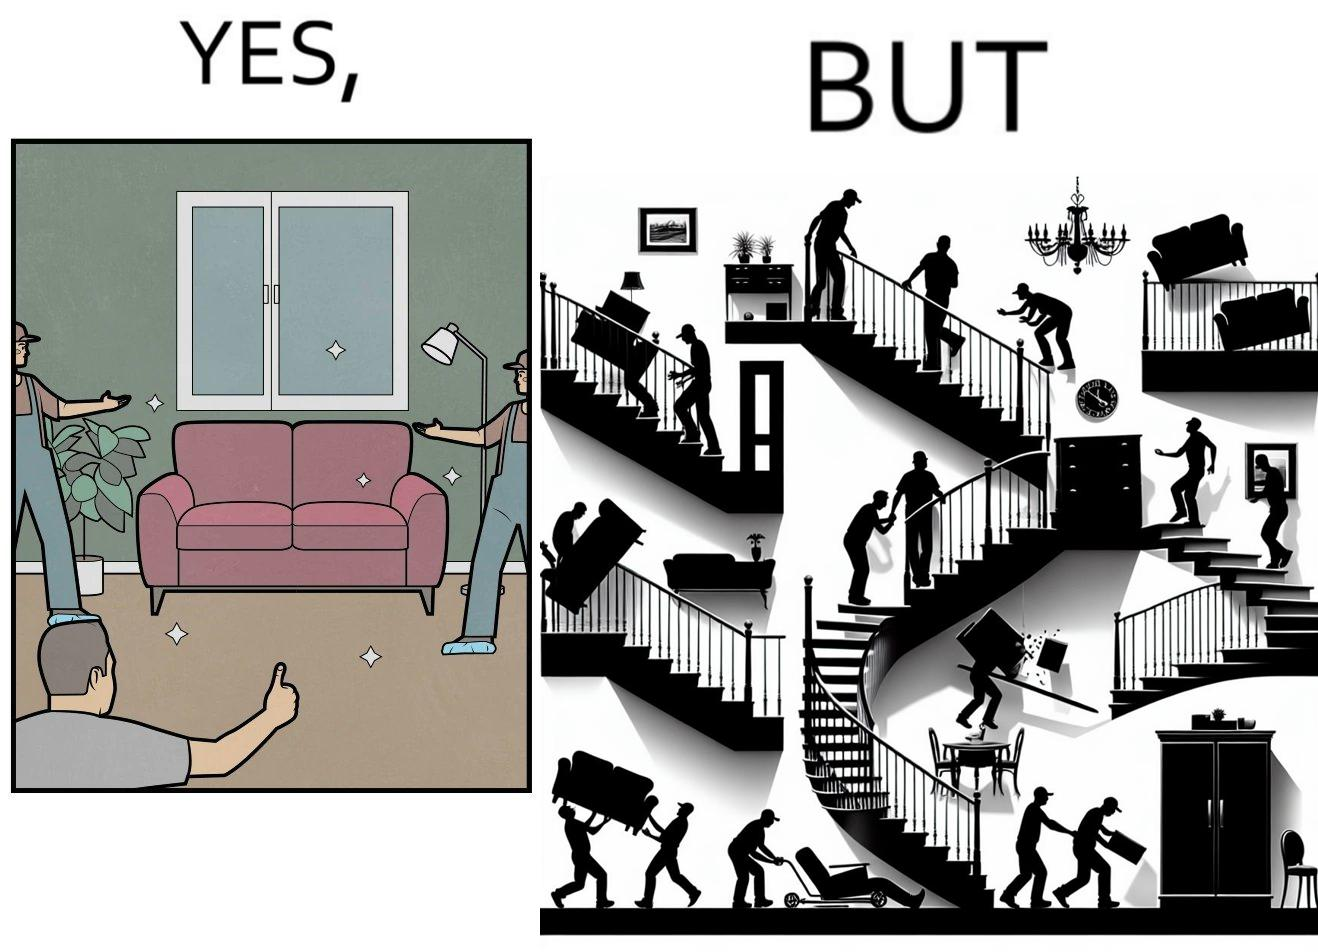Compare the left and right sides of this image. In the left part of the image: A man happy with movers who have helped move in a sofa In the right part of the image: Images show how movers have damaged a house while moving in furniture 